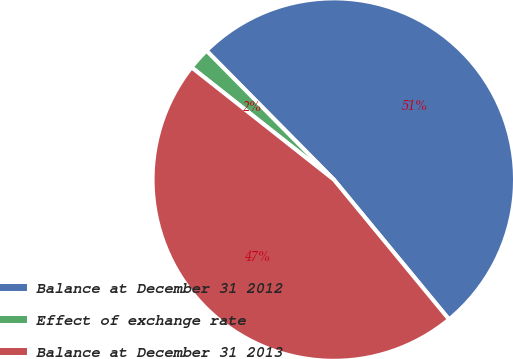Convert chart. <chart><loc_0><loc_0><loc_500><loc_500><pie_chart><fcel>Balance at December 31 2012<fcel>Effect of exchange rate<fcel>Balance at December 31 2013<nl><fcel>51.43%<fcel>1.97%<fcel>46.6%<nl></chart> 